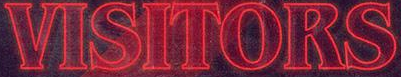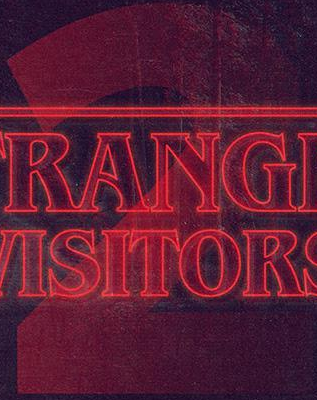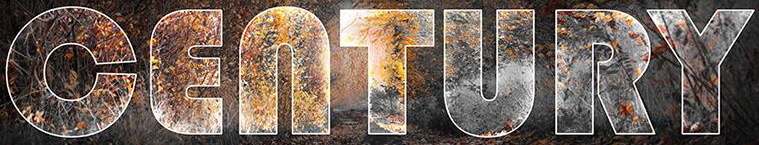Read the text content from these images in order, separated by a semicolon. VISITORS; 2; CENTURY 